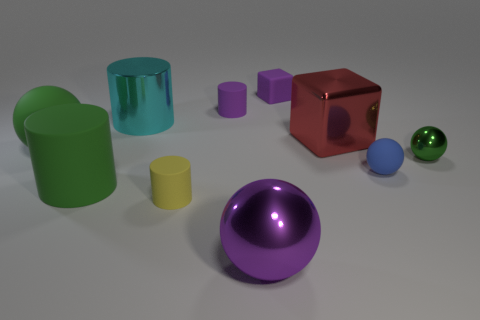Subtract all spheres. How many objects are left? 6 Subtract 0 gray spheres. How many objects are left? 10 Subtract all small cylinders. Subtract all big red metallic blocks. How many objects are left? 7 Add 8 big purple metal objects. How many big purple metal objects are left? 9 Add 7 tiny yellow metal cylinders. How many tiny yellow metal cylinders exist? 7 